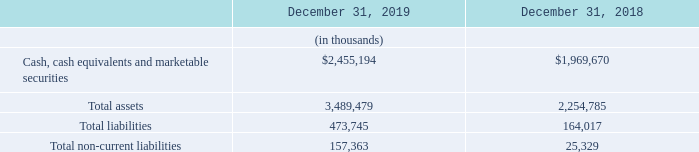Key Balance Sheet Information
Total assets increased $1,234.7 million as at December 31, 2019 compared to December 31, 2018, principally due to a $485.5 million increase in cash, cash equivalents and marketable securities mainly as a result of the public offering in September 2019, which resulted in net proceeds of $688.0 million. Business acquisitions during the year, largely due to the acquisition of 6RS, further impacted total assets through an increase in goodwill of $273.8 million, a $141.2 million increase in intangible assets and a resulting decrease in cash due to the consideration paid. The remainder of the increase is due to: the adoption of the new lease accounting standard, further discussed in the "Critical Accounting Policies and Estimates" section below, which resulted in the addition of right-of-use assets totaling $134.8 million as at December 31, 2019; a $58.3 million increase in merchant cash advances and loans receivable; a $49.8 million increase in property and equipment, largely related to leaseholds for our offices; a $49.2 million increase in trade and other receivables largely due to an increase in indirect taxes receivable, unbilled revenue related to subscription fees for Plus merchants, transaction fees and shipping charges; and a $19.4 million increase in deferred tax assets. Total liabilities increased by $309.7 million, principally as a result of the adoption of the new leasing standard, which resulted in $126.8 million of additional lease liabilities related to obtaining right-of-use assets. Accounts payable and accrued liabilities increased by $84.2 million, which was due to an increase in indirect taxes payable, payroll liabilities, and payment processing and interchange fees, partly offset by a decrease in foreign exchange forward contract liabilities. The increase was also due to income taxes payable of $69.4 million driven largely by the one-time capital gain recognized in the period. Deferred tax liabilities increased by $7.6 million, due to the acquisition of 6RS. The growth in sales of our subscription solutions offering, along with the acquisition of 6RS, resulted in an increase of deferred revenue of $21.6 million.
How much was the total assets as at December 31, 2019?
Answer scale should be: thousand. 3,489,479. How much was the total liabilities as at December 31, 2019?
Answer scale should be: thousand. 473,745. How much was the total non-current liabilities as at December 2019?
Answer scale should be: thousand. 157,363. What was the average cash, cash equivalents and marketable securities for 2018 and 2019?
Answer scale should be: thousand. ($2,455,194+$1,969,670)/2
Answer: 2212432. What is the average total assets for 2018 and 2019?
Answer scale should be: thousand. (3,489,479+2,254,785)/2
Answer: 2872132. What is the average total liabilities for 2018 and 2019?
Answer scale should be: thousand. (473,745+164,017)/2
Answer: 318881. 